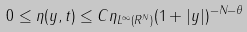<formula> <loc_0><loc_0><loc_500><loc_500>0 \leq \eta ( y , t ) \leq C \| \eta \| _ { L ^ { \infty } ( { R } ^ { N } ) } ( 1 + | y | ) ^ { - N - \theta }</formula> 